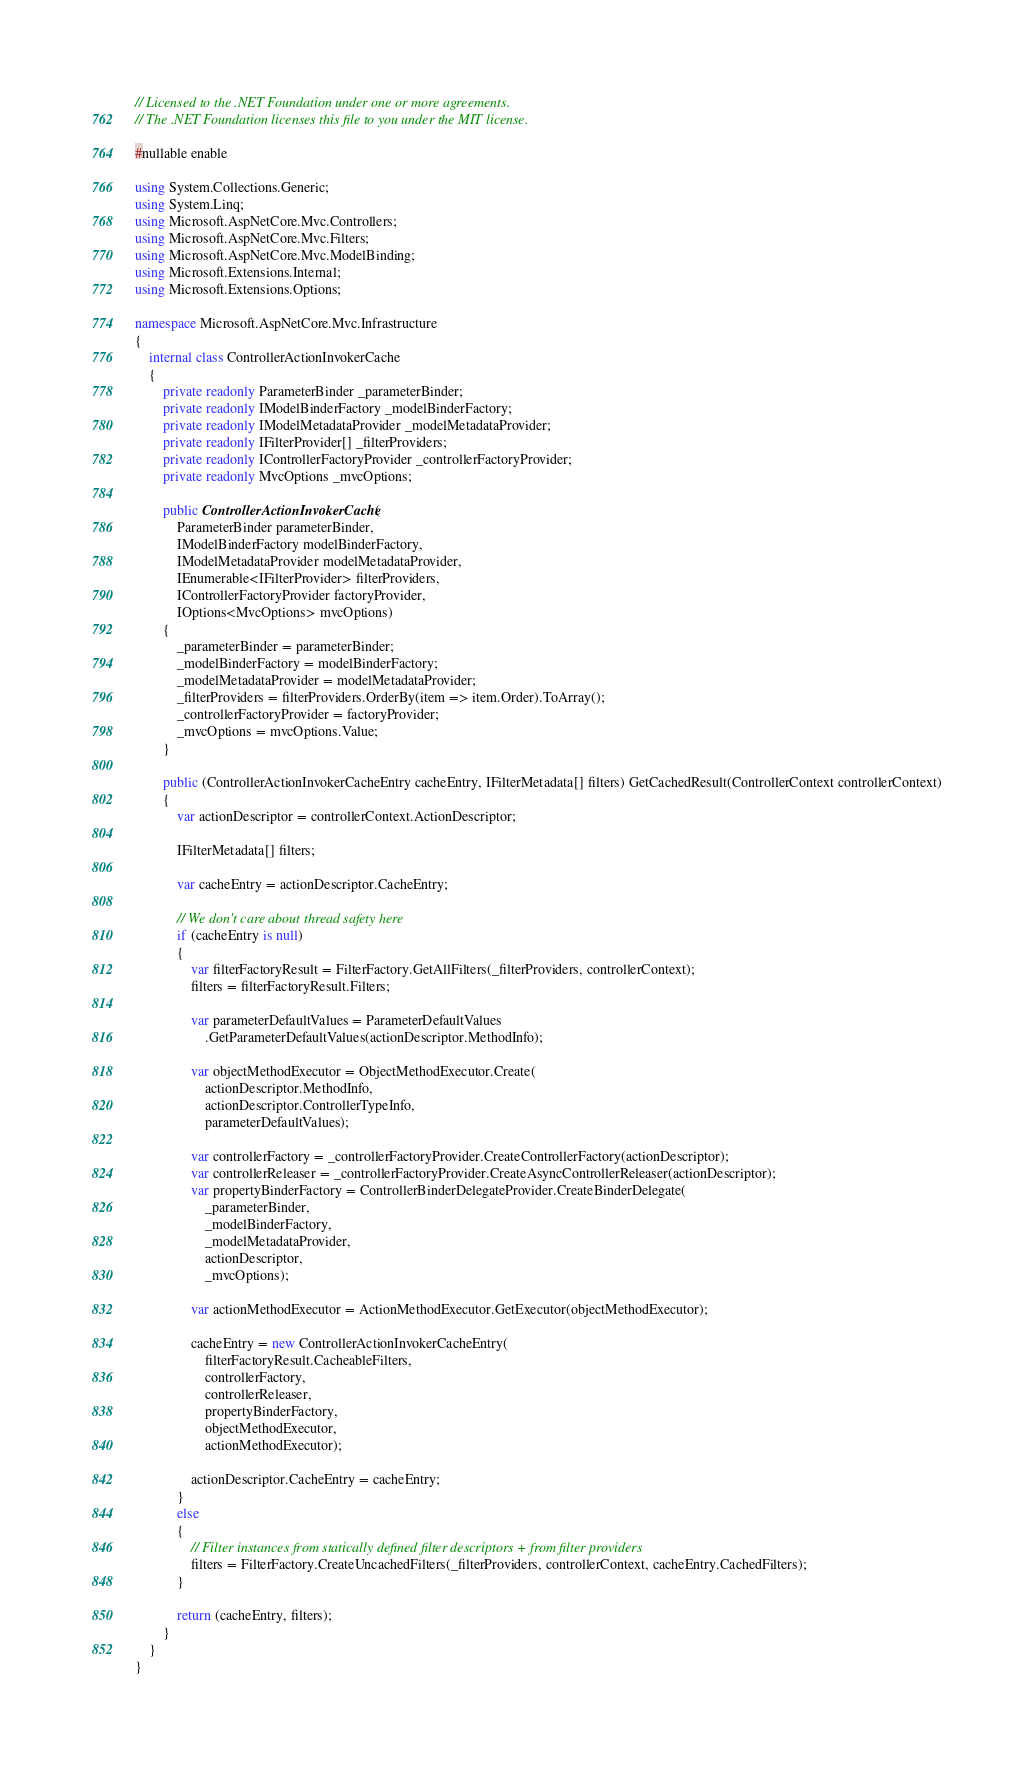<code> <loc_0><loc_0><loc_500><loc_500><_C#_>// Licensed to the .NET Foundation under one or more agreements.
// The .NET Foundation licenses this file to you under the MIT license.

#nullable enable

using System.Collections.Generic;
using System.Linq;
using Microsoft.AspNetCore.Mvc.Controllers;
using Microsoft.AspNetCore.Mvc.Filters;
using Microsoft.AspNetCore.Mvc.ModelBinding;
using Microsoft.Extensions.Internal;
using Microsoft.Extensions.Options;

namespace Microsoft.AspNetCore.Mvc.Infrastructure
{
    internal class ControllerActionInvokerCache
    {
        private readonly ParameterBinder _parameterBinder;
        private readonly IModelBinderFactory _modelBinderFactory;
        private readonly IModelMetadataProvider _modelMetadataProvider;
        private readonly IFilterProvider[] _filterProviders;
        private readonly IControllerFactoryProvider _controllerFactoryProvider;
        private readonly MvcOptions _mvcOptions;

        public ControllerActionInvokerCache(
            ParameterBinder parameterBinder,
            IModelBinderFactory modelBinderFactory,
            IModelMetadataProvider modelMetadataProvider,
            IEnumerable<IFilterProvider> filterProviders,
            IControllerFactoryProvider factoryProvider,
            IOptions<MvcOptions> mvcOptions)
        {
            _parameterBinder = parameterBinder;
            _modelBinderFactory = modelBinderFactory;
            _modelMetadataProvider = modelMetadataProvider;
            _filterProviders = filterProviders.OrderBy(item => item.Order).ToArray();
            _controllerFactoryProvider = factoryProvider;
            _mvcOptions = mvcOptions.Value;
        }

        public (ControllerActionInvokerCacheEntry cacheEntry, IFilterMetadata[] filters) GetCachedResult(ControllerContext controllerContext)
        {
            var actionDescriptor = controllerContext.ActionDescriptor;

            IFilterMetadata[] filters;

            var cacheEntry = actionDescriptor.CacheEntry;

            // We don't care about thread safety here
            if (cacheEntry is null)
            {
                var filterFactoryResult = FilterFactory.GetAllFilters(_filterProviders, controllerContext);
                filters = filterFactoryResult.Filters;

                var parameterDefaultValues = ParameterDefaultValues
                    .GetParameterDefaultValues(actionDescriptor.MethodInfo);

                var objectMethodExecutor = ObjectMethodExecutor.Create(
                    actionDescriptor.MethodInfo,
                    actionDescriptor.ControllerTypeInfo,
                    parameterDefaultValues);

                var controllerFactory = _controllerFactoryProvider.CreateControllerFactory(actionDescriptor);
                var controllerReleaser = _controllerFactoryProvider.CreateAsyncControllerReleaser(actionDescriptor);
                var propertyBinderFactory = ControllerBinderDelegateProvider.CreateBinderDelegate(
                    _parameterBinder,
                    _modelBinderFactory,
                    _modelMetadataProvider,
                    actionDescriptor,
                    _mvcOptions);

                var actionMethodExecutor = ActionMethodExecutor.GetExecutor(objectMethodExecutor);

                cacheEntry = new ControllerActionInvokerCacheEntry(
                    filterFactoryResult.CacheableFilters,
                    controllerFactory,
                    controllerReleaser,
                    propertyBinderFactory,
                    objectMethodExecutor,
                    actionMethodExecutor);

                actionDescriptor.CacheEntry = cacheEntry;
            }
            else
            {
                // Filter instances from statically defined filter descriptors + from filter providers
                filters = FilterFactory.CreateUncachedFilters(_filterProviders, controllerContext, cacheEntry.CachedFilters);
            }

            return (cacheEntry, filters);
        }
    }
}
</code> 